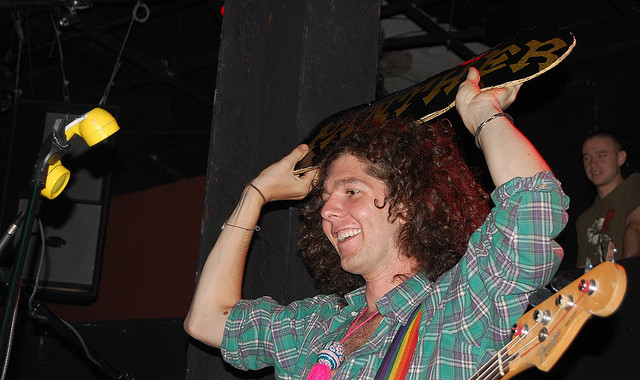<image>What sport are these people going to play? It is ambiguous what sport these people are going to play. However, it can be skateboarding or skating. What sport are these people going to play? I am not sure what sport these people are going to play. It can be either skateboarding or skating. 